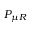<formula> <loc_0><loc_0><loc_500><loc_500>P _ { \mu R }</formula> 